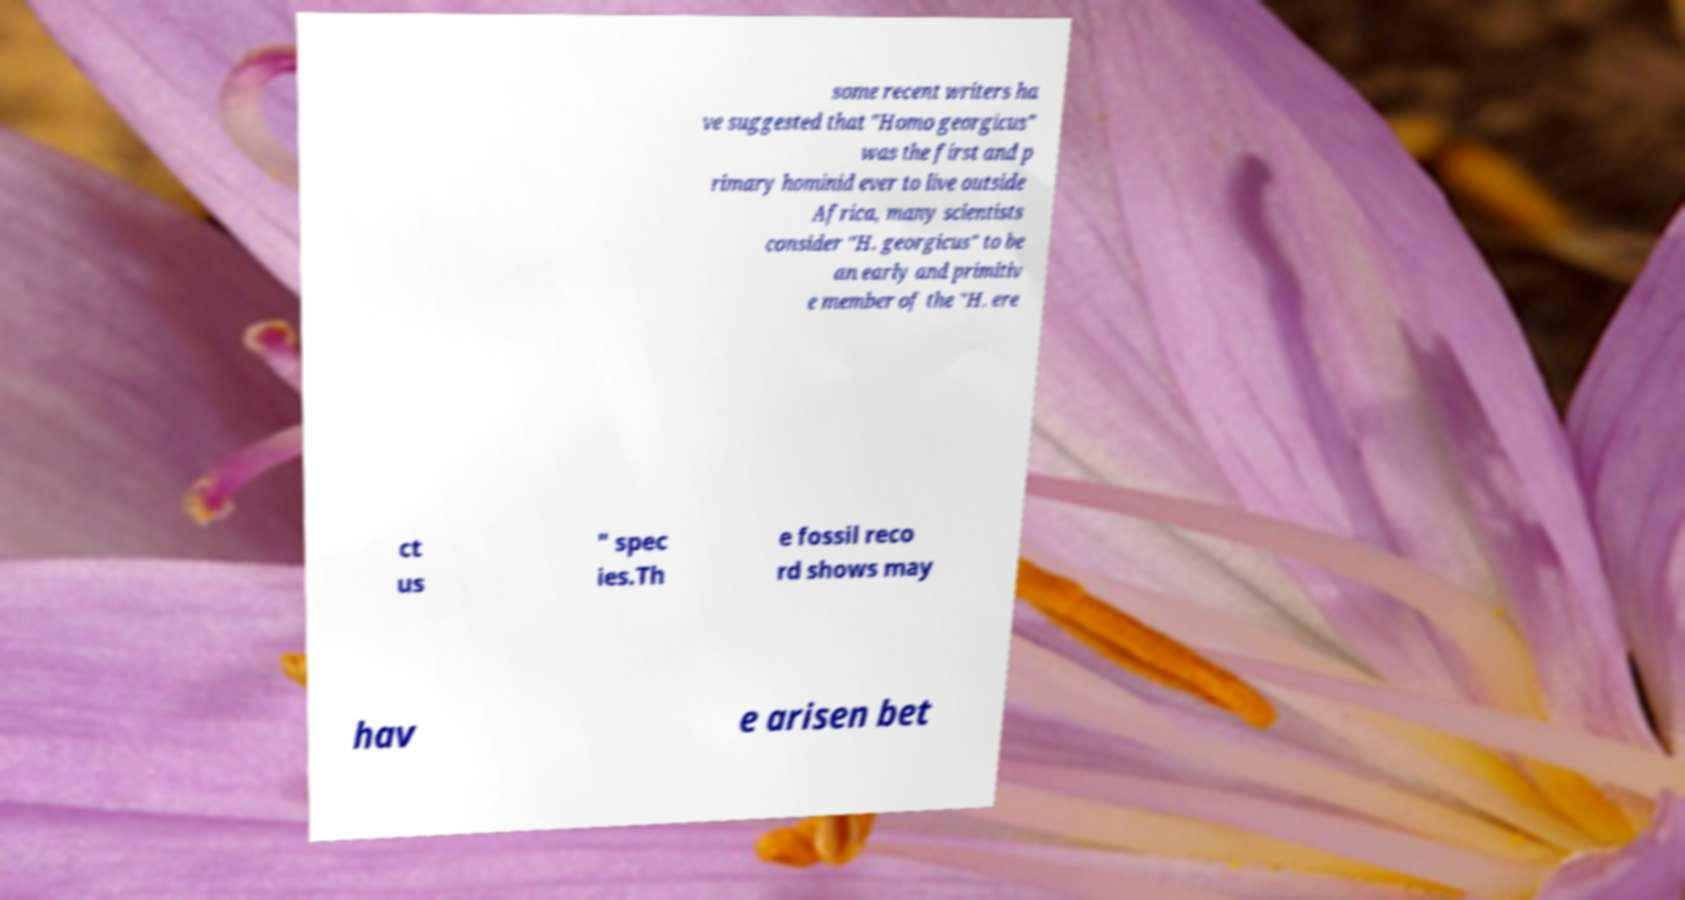For documentation purposes, I need the text within this image transcribed. Could you provide that? some recent writers ha ve suggested that "Homo georgicus" was the first and p rimary hominid ever to live outside Africa, many scientists consider "H. georgicus" to be an early and primitiv e member of the "H. ere ct us " spec ies.Th e fossil reco rd shows may hav e arisen bet 